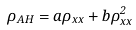Convert formula to latex. <formula><loc_0><loc_0><loc_500><loc_500>\rho _ { A H } = a \rho _ { x x } + b \rho _ { x x } ^ { 2 }</formula> 